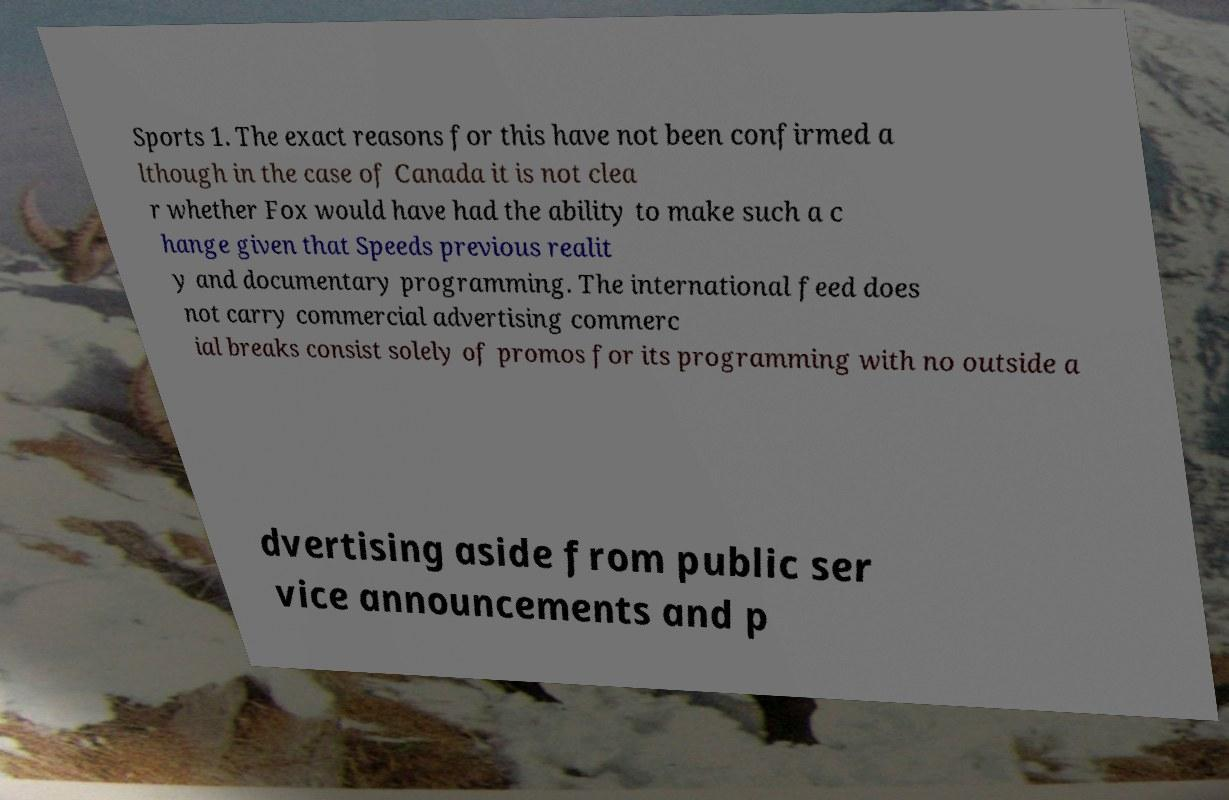Can you accurately transcribe the text from the provided image for me? Sports 1. The exact reasons for this have not been confirmed a lthough in the case of Canada it is not clea r whether Fox would have had the ability to make such a c hange given that Speeds previous realit y and documentary programming. The international feed does not carry commercial advertising commerc ial breaks consist solely of promos for its programming with no outside a dvertising aside from public ser vice announcements and p 